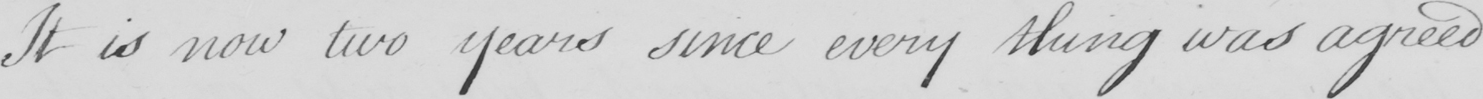What does this handwritten line say? It is now two years since every thing was agreed 